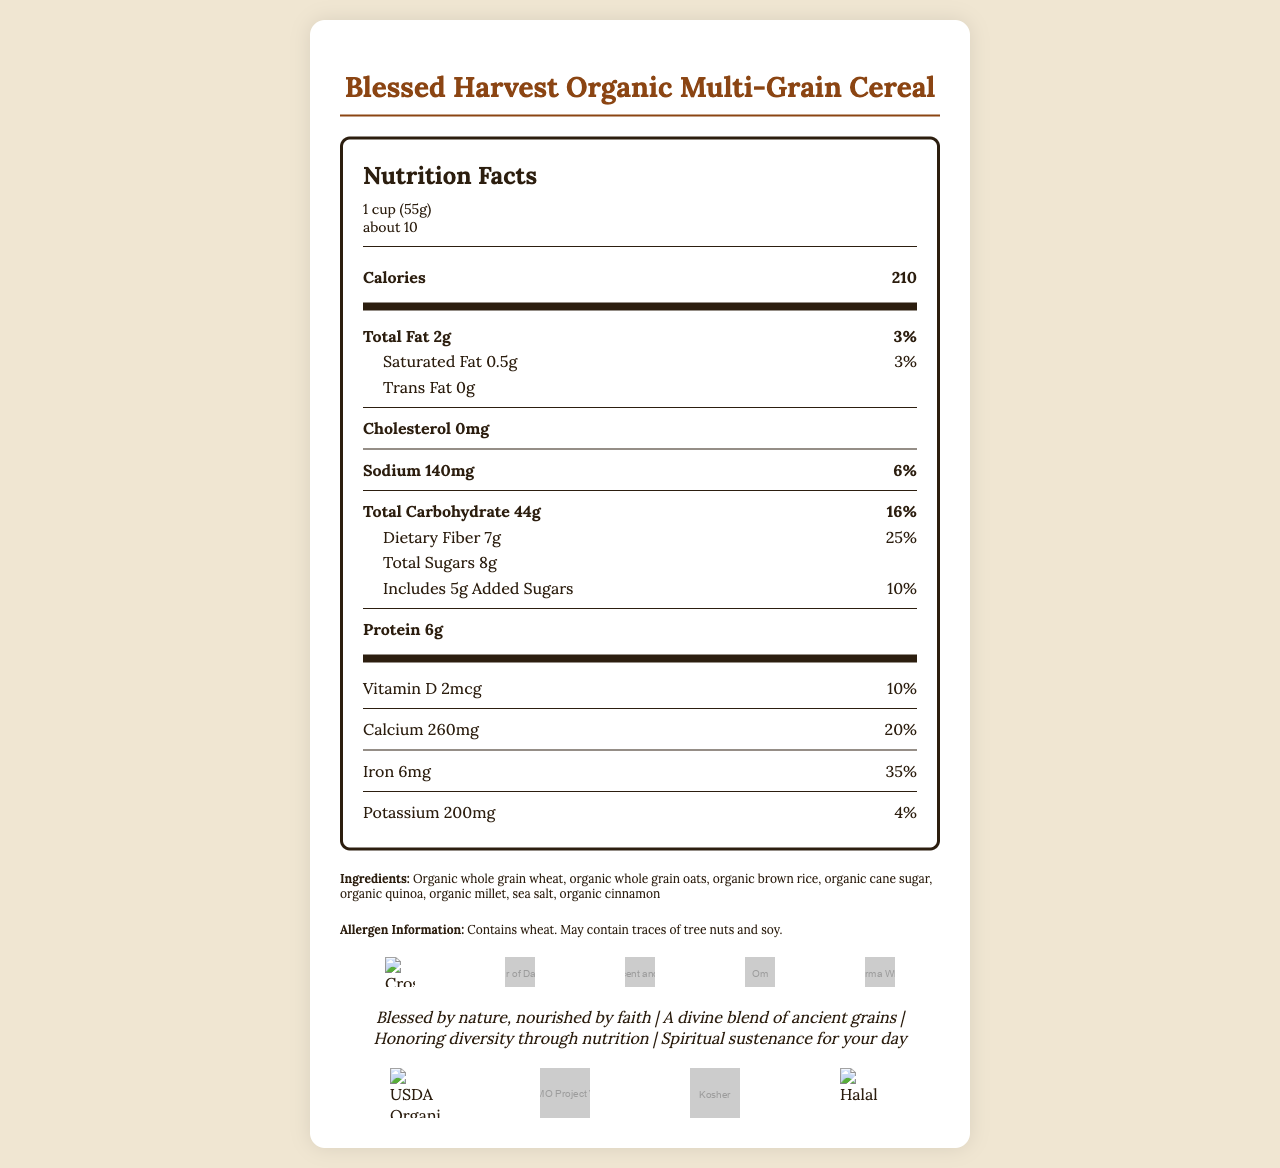what is the serving size for Blessed Harvest Organic Multi-Grain Cereal? The serving size information is displayed at the top of the nutrition facts under serving information.
Answer: 1 cup (55g) how many calories are in a single serving? The calorie count is listed prominently under the nutrition facts section.
Answer: 210 what is the amount of protein per serving? The amount of protein per serving is listed towards the bottom of the nutrition facts section.
Answer: 6g can you list the primary ingredients in the cereal? The ingredients are listed near the bottom of the document under the ingredients section.
Answer: Organic whole grain wheat, organic whole grain oats, organic brown rice, organic cane sugar, organic quinoa, organic millet, sea salt, organic cinnamon which certifications does the Blessed Harvest cereal have? The certifications are listed in the document and represented with symbols below the marketing claims section.
Answer: USDA Organic, Non-GMO Project Verified, Kosher, Halal what percentage of daily iron does the cereal provide? The daily value percentage for iron is listed in the nutrition facts section.
Answer: 35% how many servings are in a container? A. about 5 B. about 10 C. about 15 The information on servings per container is available at the top under the serving information section.
Answer: B which religious symbols are included in the marketing of the cereal? A. Cross, Om, Star of David, Crescent and Star, Dharma Wheel B. Cross, Buddha, Crescent and Star, Om, Lotus Flower C. Cross, Yin-Yang, Crescent and Star, Om, Dharma Wheel The symbols are displayed under the religious symbols section, specifically listing Cross, Star of David, Crescent and Star, Om, and Dharma Wheel.
Answer: A is this product certified kosher? The certification section includes a symbol indicating the product is kosher.
Answer: Yes describe the main goal of the Blessed Harvest Organic Multi-Grain Cereal's marketing and nutritional approach. The document highlights the use of religious symbols in marketing, the inclusive brand story, certifications for diverse dietary laws, and the focus on organic ingredients and sustainability.
Answer: The main goal is to provide a nutritious, organic cereal that appeals to diverse religious backgrounds while emphasizing faith, health, and environmental stewardship. what is the relationship between the sodium content and its daily value percentage? The sodium content is 140mg, which corresponds to 6% of the daily value, as seen in the nutrition facts section.
Answer: 140mg, 6% how much of the cereal's total carbohydrate content is dietary fiber? Out of the 44g of total carbohydrates, 7g is dietary fiber, according to the nutrition facts section.
Answer: 7g what is the daily value percentage of vitamin D provided by the cereal? The daily value percentage for vitamin D is listed as 10% in the nutrition facts section.
Answer: 10% which allergens might be present in this cereal? The allergen information section notes the presence of wheat and the potential for traces of tree nuts and soy.
Answer: Wheat, traces of tree nuts, and soy can this product be composted? The packaging features section states that the inner bag is made from compostable materials.
Answer: Yes, the inner bag is made from compostable materials. how much-saturated fat does the cereal contain? A. 0g B. 0.5g C. 1g The nutrition facts section lists saturated fat content as 0.5g.
Answer: B what is the main message conveyed by the marketing claims? The marketing claims section has phrases like "Blessed by nature, nourished by faith" and "Honoring diversity through nutrition," indicating the central marketing message.
Answer: The cereal aims to provide nourishment through faith and ancient grains to honor diversity and offer spiritual sustenance. who founded the Blessed Harvest brand? According to the brand story, the brand was founded by a diverse group of nutritionists and religious scholars.
Answer: A diverse group of nutritionists and religious scholars what is the potassium content per serving? The nutrition facts section lists potassium content as 200mg.
Answer: 200mg what types of daily values (percentages) are provided for the nutrients? The document lists daily values for these specific nutrients in the nutrition facts section.
Answer: Total fat, saturated fat, sodium, total carbohydrate, dietary fiber, added sugars, vitamin D, calcium, iron, potassium which function does the QR code on the packaging serve? According to the packaging features section, the QR code provides linkage to interfaith nutrition resources.
Answer: It links to interfaith nutrition resources. does the cereal contain cholesterol? The nutrition facts section lists cholesterol as 0mg.
Answer: No how do the certifications relate to the product's inclusivity? The certifications listed emphasize inclusivity by ensuring the product caters to different dietary laws and standards, reflecting the brand's mission of honoring diversity.
Answer: The certifications include USDA Organic, Non-GMO Project Verified, Kosher, and Halal, ensuring that the product meets diverse dietary laws and environmental standards. 